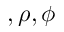<formula> <loc_0><loc_0><loc_500><loc_500>\ u , \rho , \phi</formula> 